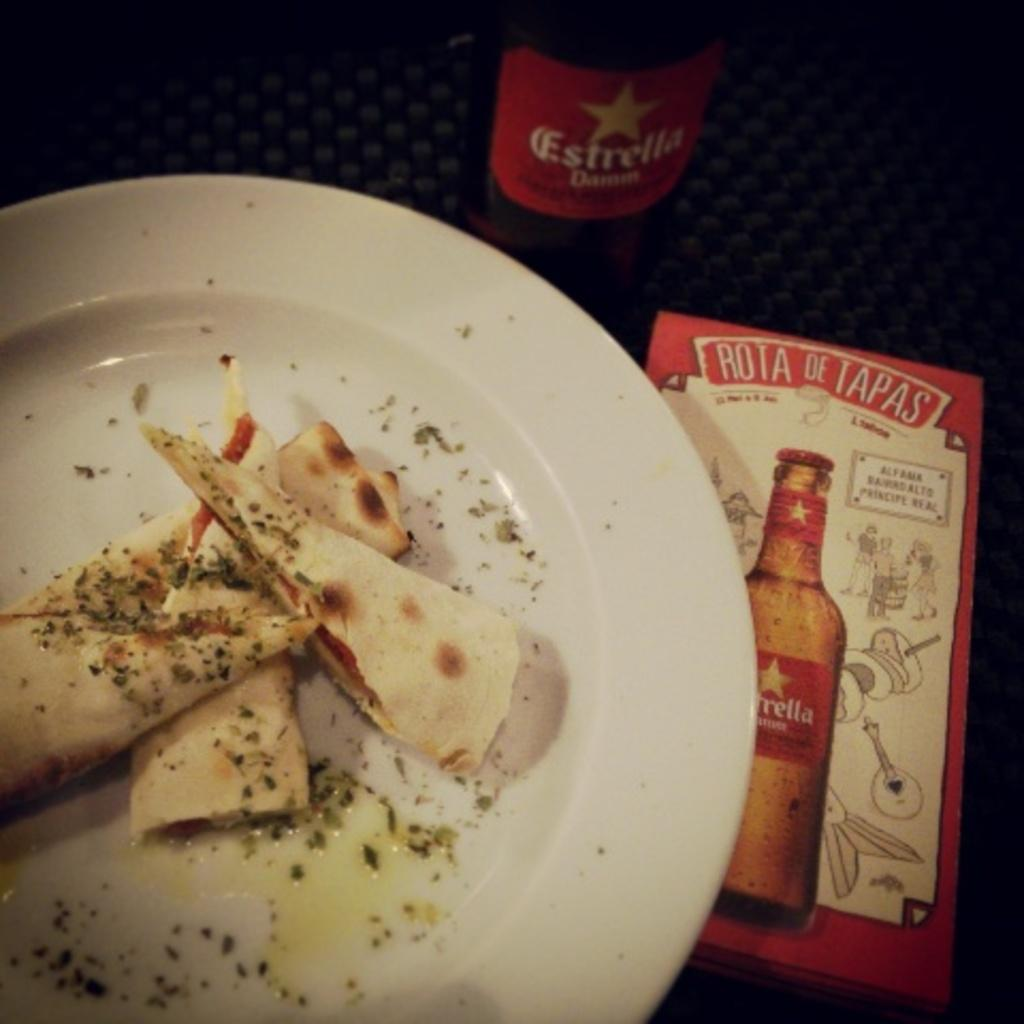What is the primary object on which the food is placed in the image? There is a plate in the image, and the food is placed on it. What other objects can be seen in the image besides the plate and food? There is a box and a bottle visible in the image. Where are these objects located in the image? All these objects are placed on a table. How many babies are crawling under the table in the image? There are no babies present in the image; it only shows a plate with food, a box, a bottle, and a table. 